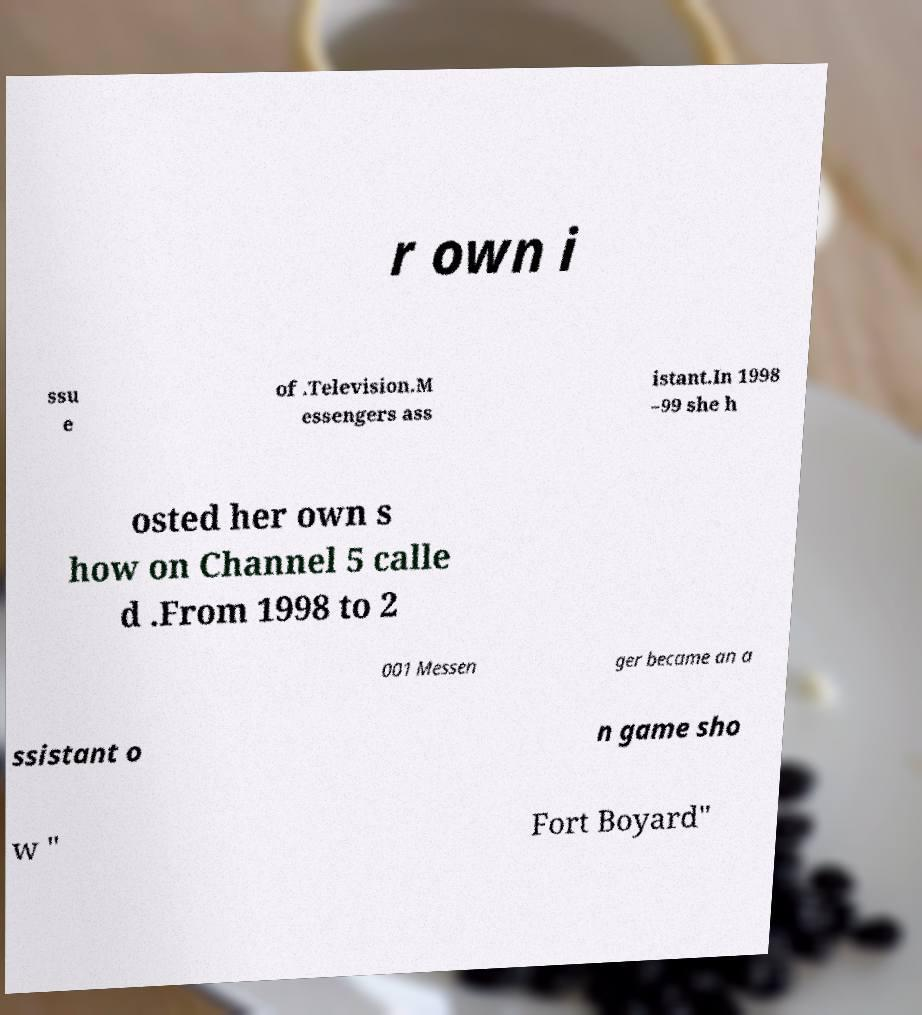Can you read and provide the text displayed in the image?This photo seems to have some interesting text. Can you extract and type it out for me? r own i ssu e of .Television.M essengers ass istant.In 1998 –99 she h osted her own s how on Channel 5 calle d .From 1998 to 2 001 Messen ger became an a ssistant o n game sho w " Fort Boyard" 